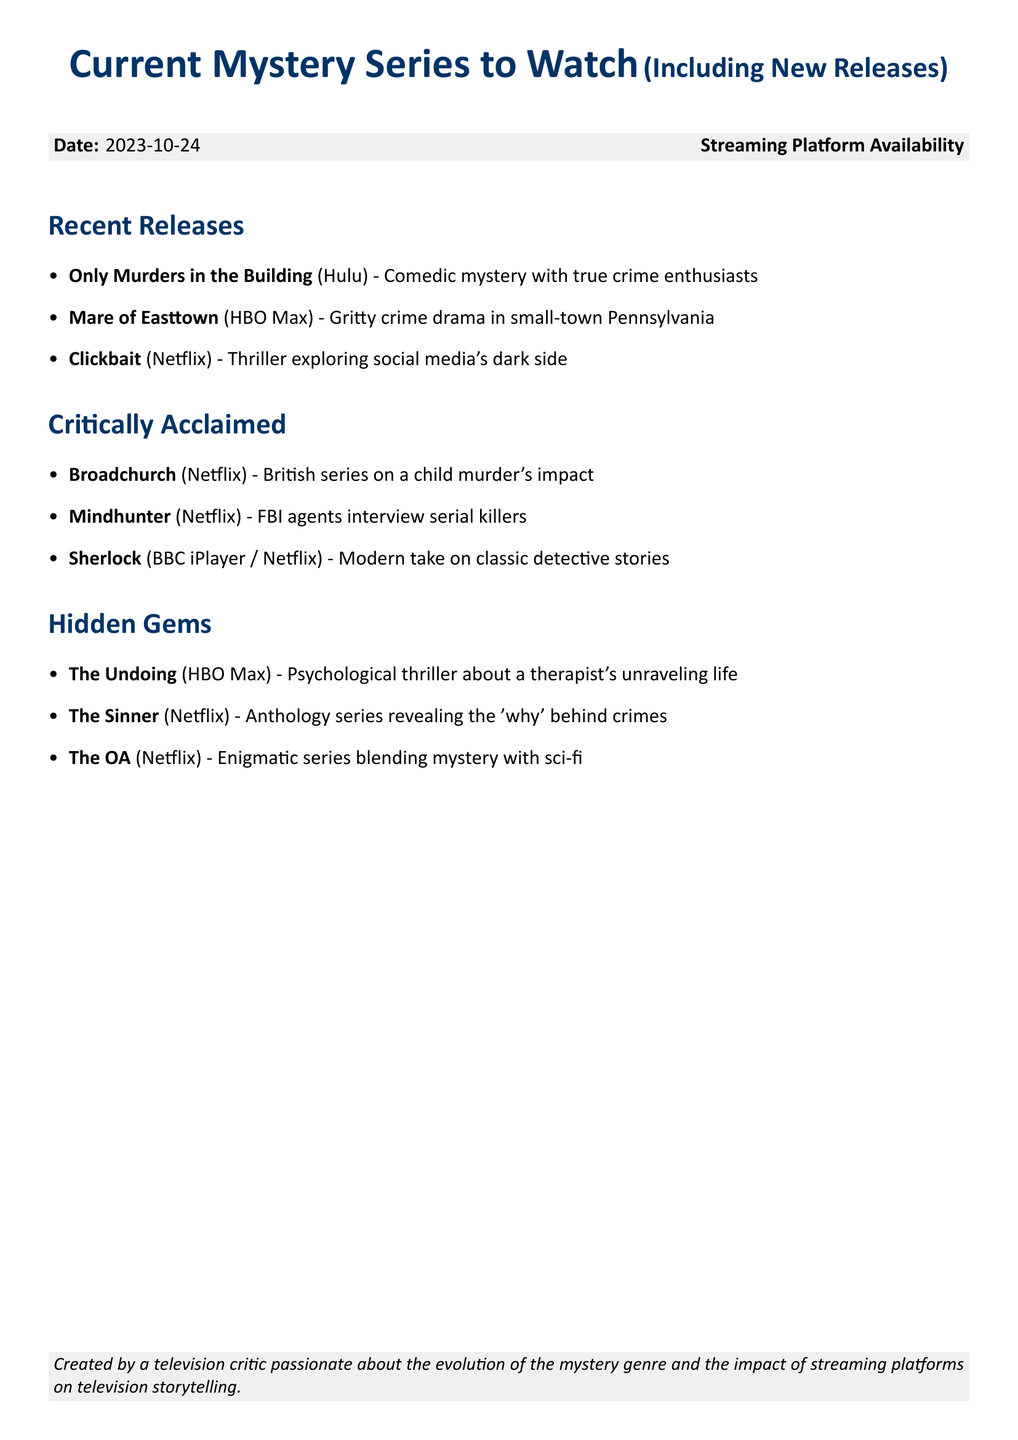What is the first mystery series listed under Recent Releases? The first mystery series listed in the Recent Releases section is "Only Murders in the Building."
Answer: Only Murders in the Building How many series are listed under Critically Acclaimed? There are three series mentioned in the Critically Acclaimed section.
Answer: 3 Which streaming platform is "Mare of Easttown" available on? "Mare of Easttown" is available on HBO Max.
Answer: HBO Max Name one series from the Hidden Gems section. The Hidden Gems section includes the series "The Undoing."
Answer: The Undoing What is the focus of the series "Clickbait"? "Clickbait" explores social media's dark side.
Answer: Social media's dark side Which platform has "Sherlock" available? "Sherlock" can be found on BBC iPlayer and Netflix.
Answer: BBC iPlayer / Netflix 